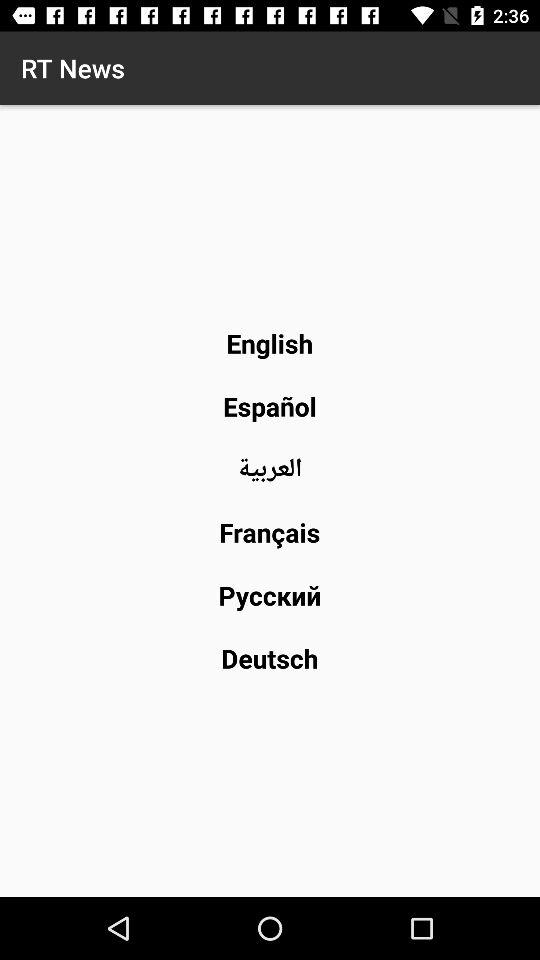What is the name of the application? The name of the application is "RT News". 